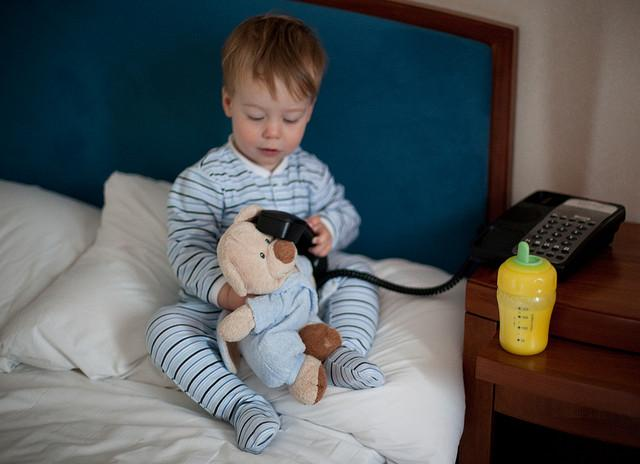What does the child imagine his toy bear does now? Please explain your reasoning. phone call. The bear is making a call. 